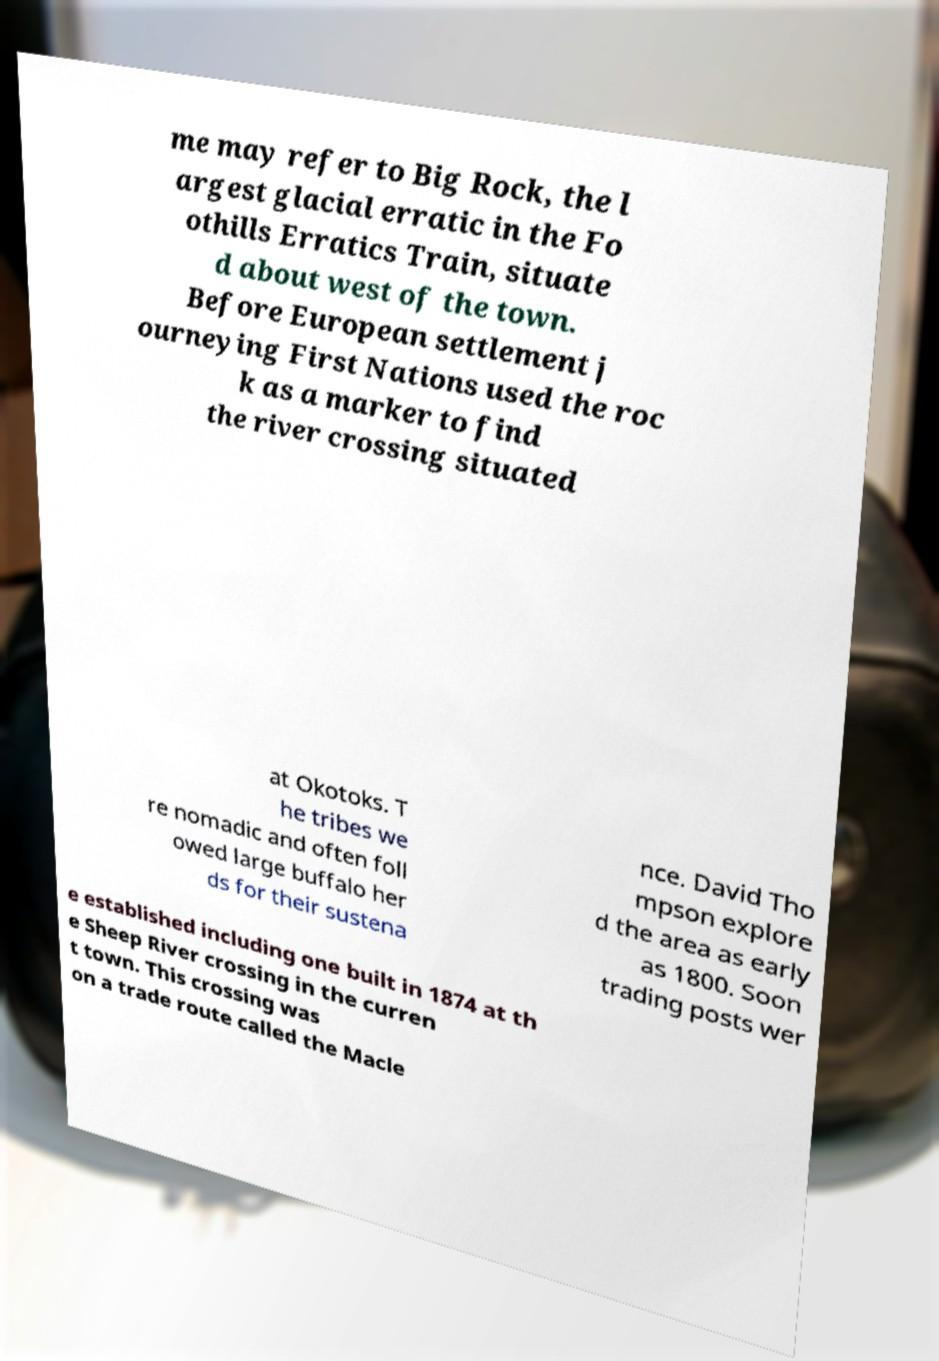Please read and relay the text visible in this image. What does it say? me may refer to Big Rock, the l argest glacial erratic in the Fo othills Erratics Train, situate d about west of the town. Before European settlement j ourneying First Nations used the roc k as a marker to find the river crossing situated at Okotoks. T he tribes we re nomadic and often foll owed large buffalo her ds for their sustena nce. David Tho mpson explore d the area as early as 1800. Soon trading posts wer e established including one built in 1874 at th e Sheep River crossing in the curren t town. This crossing was on a trade route called the Macle 